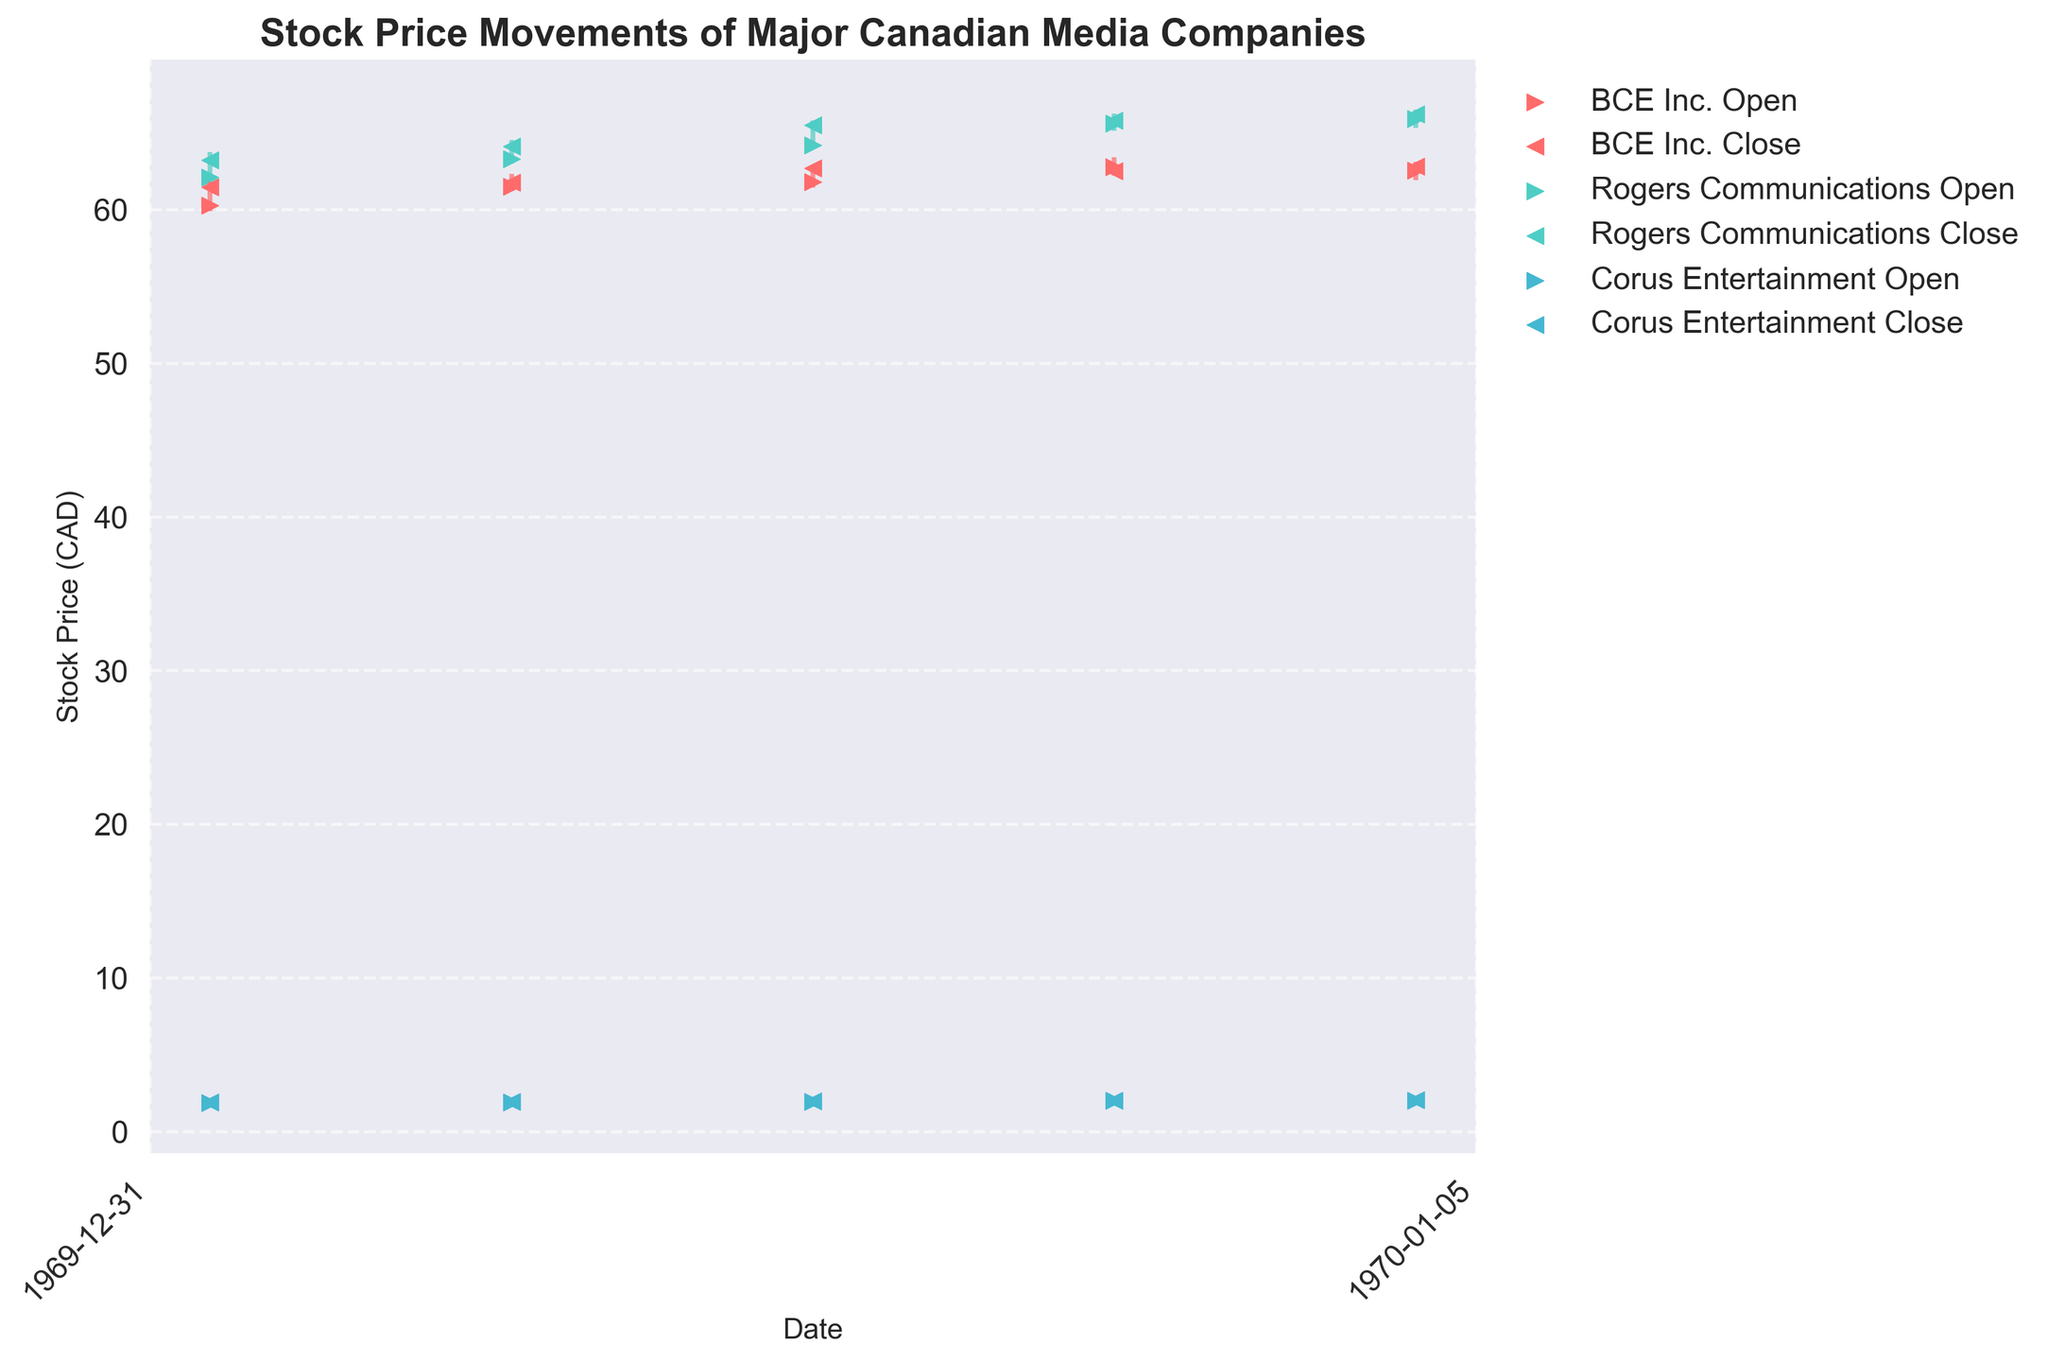Which company had the highest stock price on May 3rd? On May 3rd, look for the highest "High" value among all companies. Rogers Communications had the highest stock price with a "High" of 65.80.
Answer: Rogers Communications How did the closing price of BCE Inc. change from May 1st to May 5th? Look at the "Close" prices for BCE Inc. on May 1st and May 5th. The closing price moved from 61.45 to 62.80.
Answer: Increased Which company showed a trend of increasing stock prices from May 1st to May 5th? Check each company's "Close" prices from May 1st to May 5th to see if there is a consistent upward trend. Rogers Communications and Corus Entertainment both show consistent increases in their closing prices over the period.
Answer: Rogers Communications and Corus Entertainment What was the largest difference between the opening and closing prices for Rogers Communications during the week? Find the differences between the "Open" and "Close" prices for each day for Rogers Communications, and identify the maximum difference. On May 4th, the difference was the largest at 0.20 (65.60 Open, 65.80 Close).
Answer: 0.20 Which day had the highest opening price for Corus Entertainment? Look at the "Open" prices for Corus Entertainment for each day and find the highest value. The highest opening price was 2.01 on May 5th.
Answer: May 5th Did BCE Inc. or Rogers Communications have a higher closing price on May 2nd? Compare the "Close" prices for BCE Inc. and Rogers Communications on May 2nd. Rogers Communications had a higher closing price at 64.10 compared to BCE Inc.'s 61.75.
Answer: Rogers Communications What is the average closing price of Corus Entertainment over the five days? Sum the "Close" prices of Corus Entertainment for the five days and divide by 5 (1.88, 1.92, 1.98, 2.00, 2.05). The total is 9.83, and the average is 9.83 / 5.
Answer: 1.97 Which company had the greatest stock price volatility on May 1st? Compute the differences between "High" and "Low" prices for each company on May 1st. BCE Inc. had a range of 1.90 (61.80 - 59.90), Rogers Communications had 1.90 (63.75 - 61.85), and Corus Entertainment had 0.12 (1.92 - 1.80). Both BCE Inc. and Rogers Communications had the greatest range.
Answer: BCE Inc. and Rogers Communications How did the stock price range (High - Low) for BCE Inc. change from May 1st to May 5th? Calculate the range for each day and compare. The ranges are: May 1st (1.90), May 2nd (1.10), May 3rd (1.50), May 4th (1.20), May 5th (1.20). Thus, the range fluctuated but generally decreased.
Answer: Decreased 